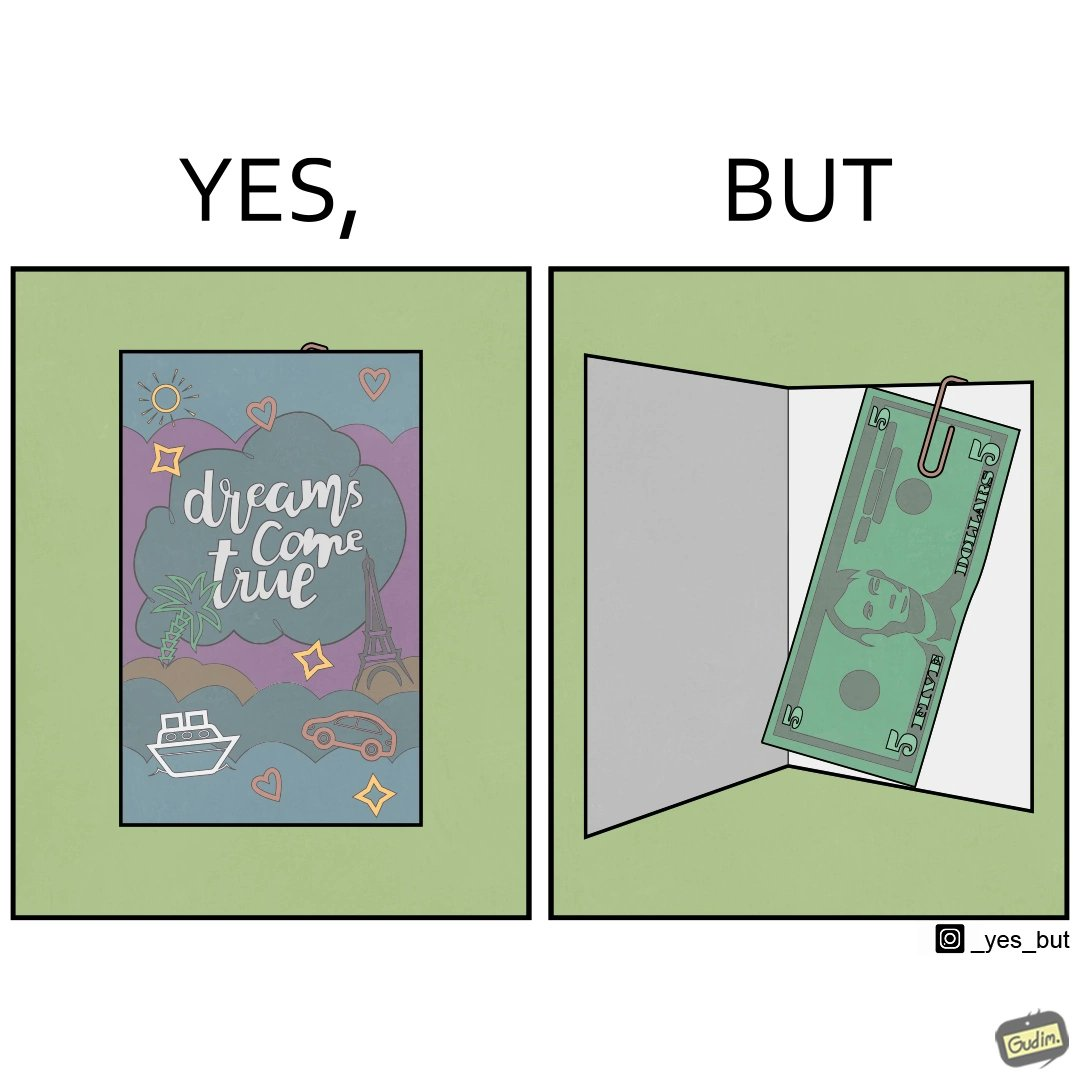Describe the contrast between the left and right parts of this image. In the left part of the image: The image shows the front side of a card with the text saying "dreams come true". There are also various drawings of sun, starts, hearts, ships, cars and eiffel tower on the card. In the right part of the image: The image shows a 5 US dollar bill clipped to a card. 